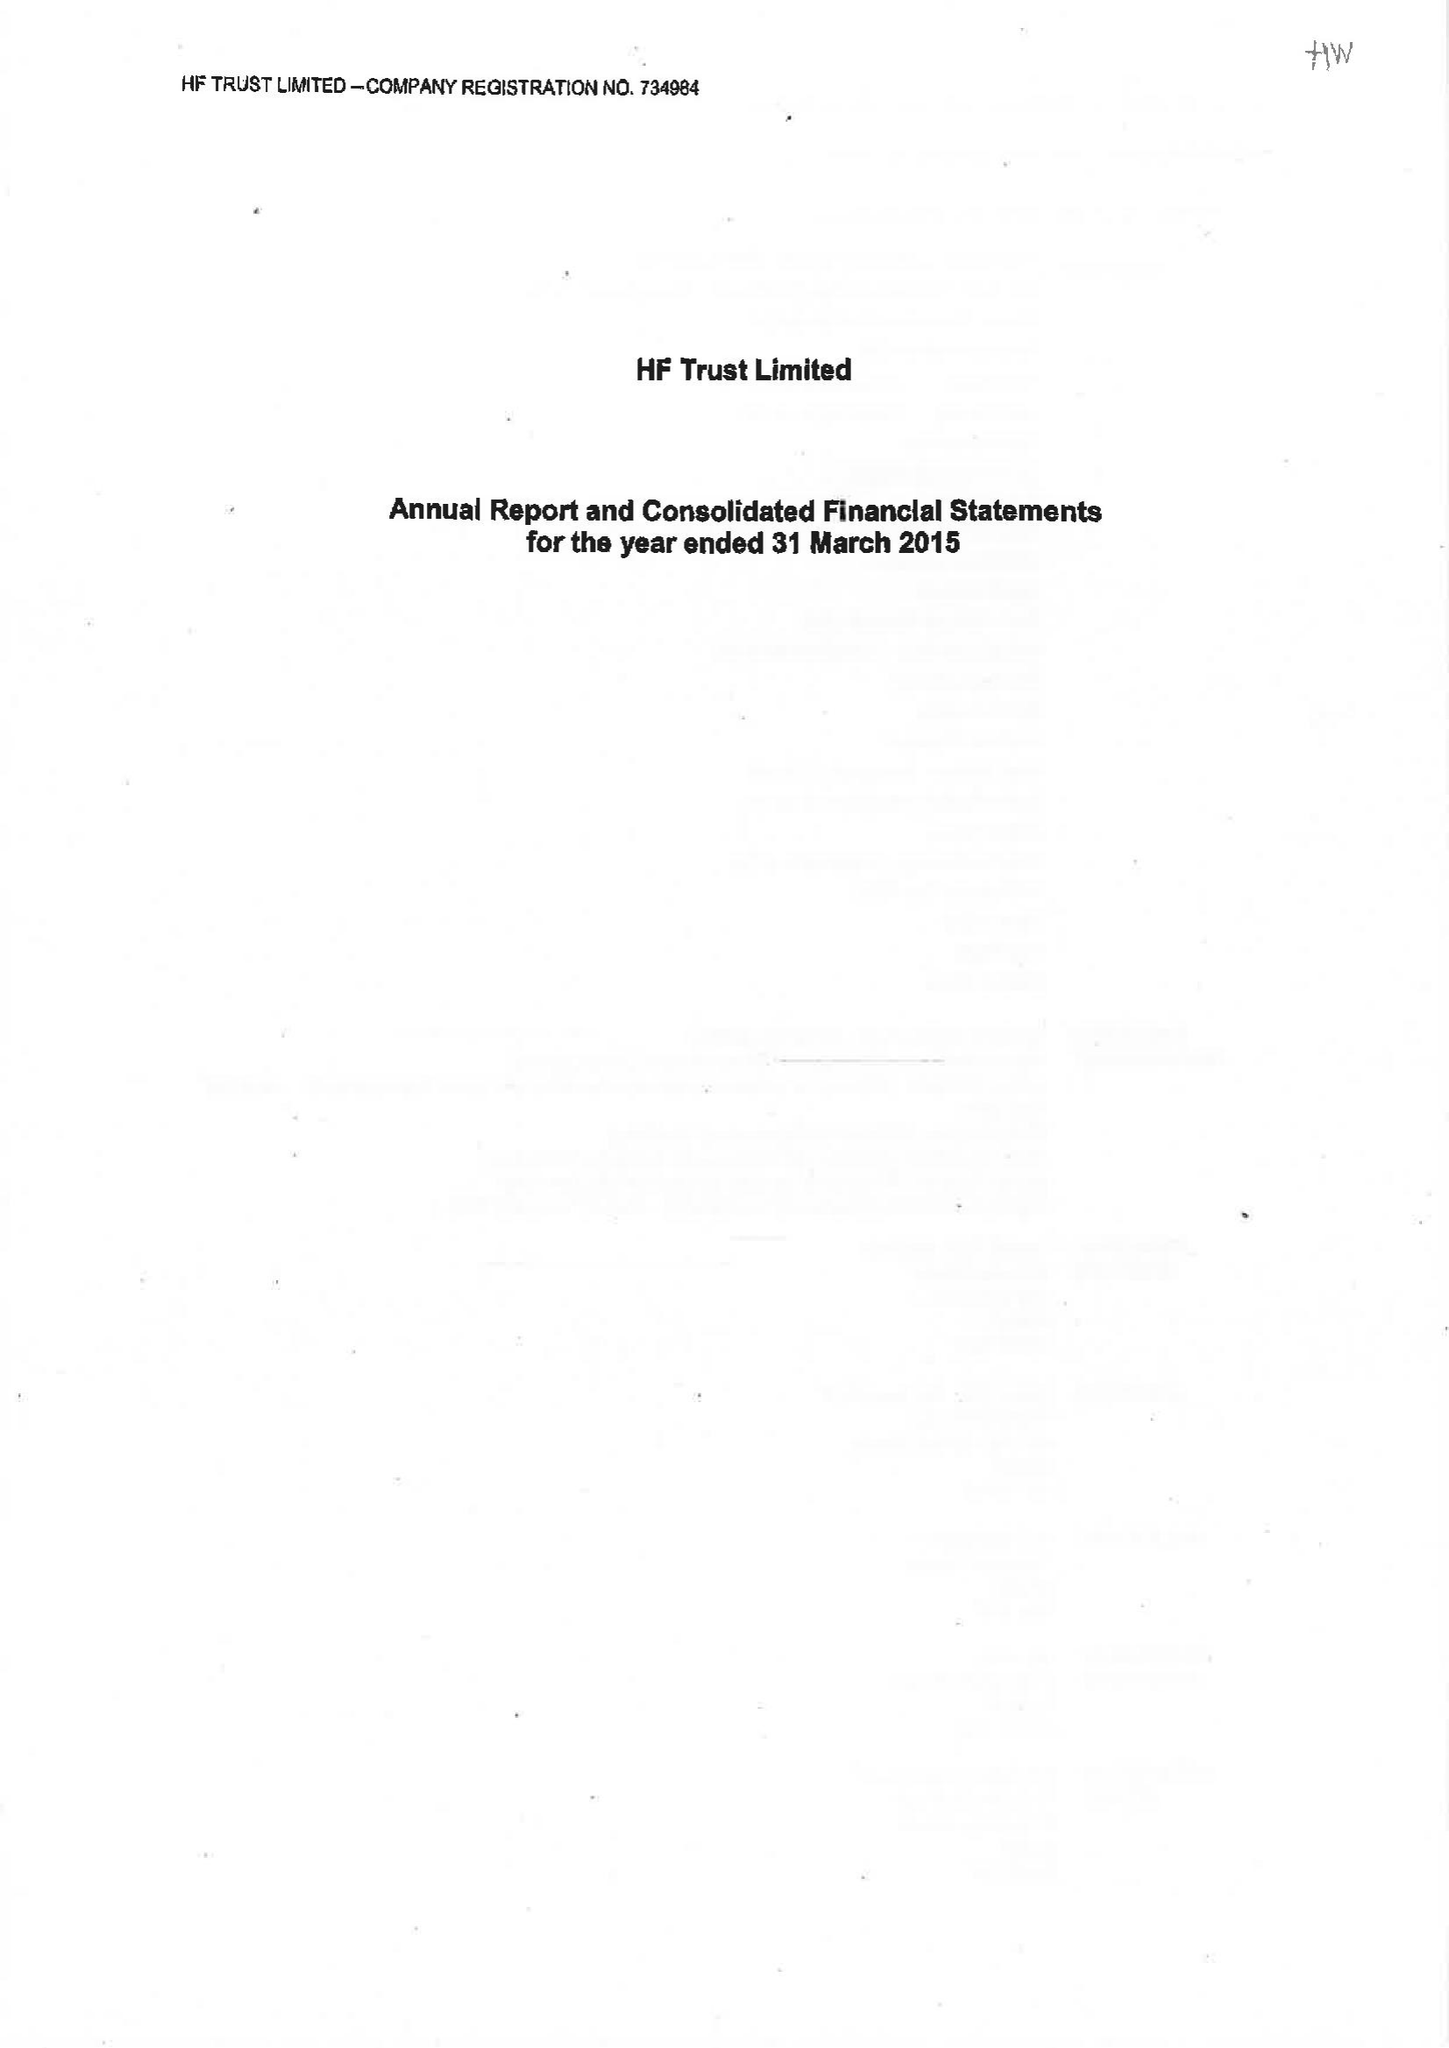What is the value for the address__postcode?
Answer the question using a single word or phrase. BS16 7FL 